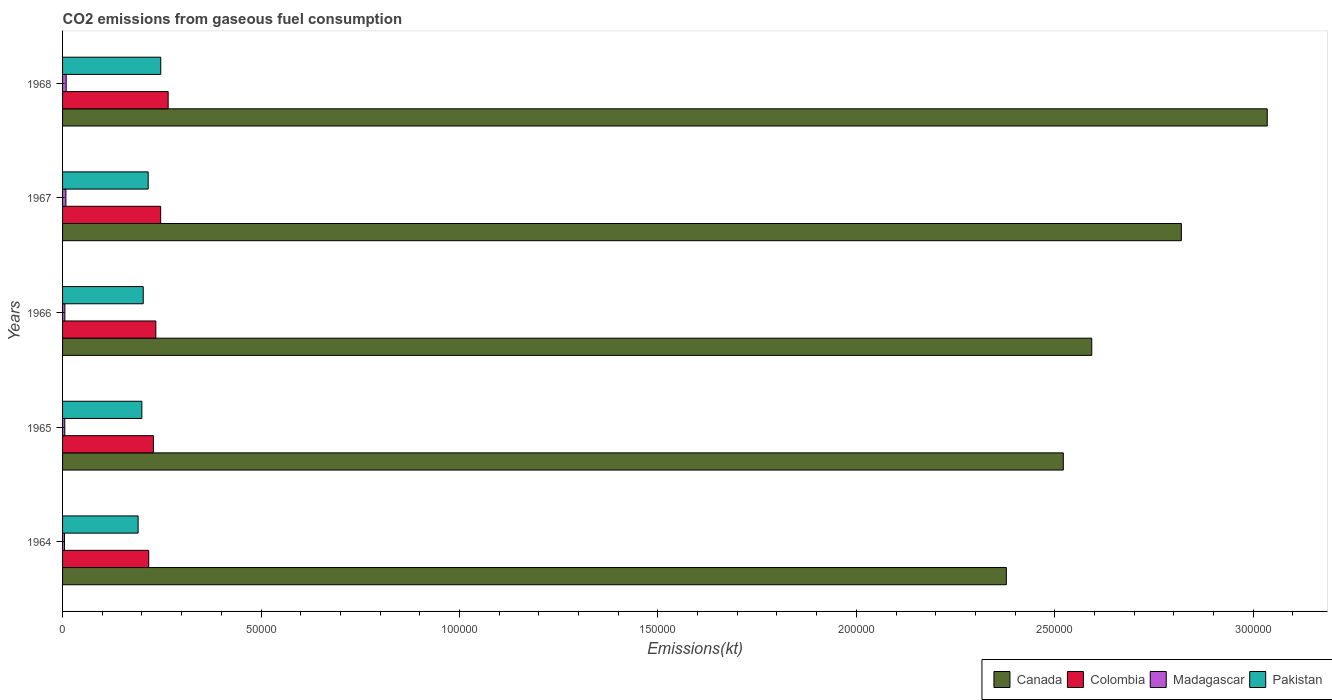How many groups of bars are there?
Your response must be concise. 5. Are the number of bars on each tick of the Y-axis equal?
Your answer should be compact. Yes. What is the label of the 3rd group of bars from the top?
Ensure brevity in your answer.  1966. What is the amount of CO2 emitted in Canada in 1966?
Your answer should be compact. 2.59e+05. Across all years, what is the maximum amount of CO2 emitted in Colombia?
Provide a succinct answer. 2.66e+04. Across all years, what is the minimum amount of CO2 emitted in Colombia?
Keep it short and to the point. 2.17e+04. In which year was the amount of CO2 emitted in Colombia maximum?
Provide a short and direct response. 1968. In which year was the amount of CO2 emitted in Pakistan minimum?
Provide a short and direct response. 1964. What is the total amount of CO2 emitted in Pakistan in the graph?
Ensure brevity in your answer.  1.06e+05. What is the difference between the amount of CO2 emitted in Madagascar in 1966 and that in 1967?
Offer a terse response. -264.02. What is the difference between the amount of CO2 emitted in Madagascar in 1967 and the amount of CO2 emitted in Colombia in 1968?
Make the answer very short. -2.58e+04. What is the average amount of CO2 emitted in Pakistan per year?
Ensure brevity in your answer.  2.11e+04. In the year 1966, what is the difference between the amount of CO2 emitted in Colombia and amount of CO2 emitted in Canada?
Your answer should be very brief. -2.36e+05. What is the ratio of the amount of CO2 emitted in Canada in 1965 to that in 1966?
Your answer should be very brief. 0.97. What is the difference between the highest and the second highest amount of CO2 emitted in Madagascar?
Provide a short and direct response. 69.67. What is the difference between the highest and the lowest amount of CO2 emitted in Colombia?
Make the answer very short. 4895.44. Is the sum of the amount of CO2 emitted in Canada in 1966 and 1968 greater than the maximum amount of CO2 emitted in Colombia across all years?
Your answer should be very brief. Yes. Is it the case that in every year, the sum of the amount of CO2 emitted in Pakistan and amount of CO2 emitted in Madagascar is greater than the sum of amount of CO2 emitted in Canada and amount of CO2 emitted in Colombia?
Keep it short and to the point. No. What does the 3rd bar from the bottom in 1964 represents?
Provide a short and direct response. Madagascar. Are the values on the major ticks of X-axis written in scientific E-notation?
Your answer should be very brief. No. What is the title of the graph?
Offer a terse response. CO2 emissions from gaseous fuel consumption. What is the label or title of the X-axis?
Make the answer very short. Emissions(kt). What is the label or title of the Y-axis?
Make the answer very short. Years. What is the Emissions(kt) of Canada in 1964?
Ensure brevity in your answer.  2.38e+05. What is the Emissions(kt) in Colombia in 1964?
Provide a short and direct response. 2.17e+04. What is the Emissions(kt) in Madagascar in 1964?
Your response must be concise. 484.04. What is the Emissions(kt) in Pakistan in 1964?
Your response must be concise. 1.90e+04. What is the Emissions(kt) in Canada in 1965?
Provide a short and direct response. 2.52e+05. What is the Emissions(kt) of Colombia in 1965?
Provide a succinct answer. 2.29e+04. What is the Emissions(kt) in Madagascar in 1965?
Make the answer very short. 557.38. What is the Emissions(kt) of Pakistan in 1965?
Provide a succinct answer. 2.00e+04. What is the Emissions(kt) of Canada in 1966?
Give a very brief answer. 2.59e+05. What is the Emissions(kt) of Colombia in 1966?
Offer a terse response. 2.35e+04. What is the Emissions(kt) in Madagascar in 1966?
Keep it short and to the point. 579.39. What is the Emissions(kt) of Pakistan in 1966?
Your answer should be very brief. 2.03e+04. What is the Emissions(kt) in Canada in 1967?
Make the answer very short. 2.82e+05. What is the Emissions(kt) in Colombia in 1967?
Keep it short and to the point. 2.47e+04. What is the Emissions(kt) of Madagascar in 1967?
Make the answer very short. 843.41. What is the Emissions(kt) in Pakistan in 1967?
Your answer should be very brief. 2.16e+04. What is the Emissions(kt) in Canada in 1968?
Your response must be concise. 3.04e+05. What is the Emissions(kt) in Colombia in 1968?
Provide a short and direct response. 2.66e+04. What is the Emissions(kt) in Madagascar in 1968?
Provide a short and direct response. 913.08. What is the Emissions(kt) of Pakistan in 1968?
Your answer should be compact. 2.47e+04. Across all years, what is the maximum Emissions(kt) in Canada?
Your response must be concise. 3.04e+05. Across all years, what is the maximum Emissions(kt) in Colombia?
Provide a short and direct response. 2.66e+04. Across all years, what is the maximum Emissions(kt) in Madagascar?
Provide a short and direct response. 913.08. Across all years, what is the maximum Emissions(kt) in Pakistan?
Ensure brevity in your answer.  2.47e+04. Across all years, what is the minimum Emissions(kt) in Canada?
Your answer should be very brief. 2.38e+05. Across all years, what is the minimum Emissions(kt) in Colombia?
Keep it short and to the point. 2.17e+04. Across all years, what is the minimum Emissions(kt) in Madagascar?
Give a very brief answer. 484.04. Across all years, what is the minimum Emissions(kt) of Pakistan?
Your answer should be very brief. 1.90e+04. What is the total Emissions(kt) of Canada in the graph?
Your answer should be compact. 1.33e+06. What is the total Emissions(kt) in Colombia in the graph?
Make the answer very short. 1.19e+05. What is the total Emissions(kt) in Madagascar in the graph?
Ensure brevity in your answer.  3377.31. What is the total Emissions(kt) in Pakistan in the graph?
Give a very brief answer. 1.06e+05. What is the difference between the Emissions(kt) of Canada in 1964 and that in 1965?
Your answer should be very brief. -1.44e+04. What is the difference between the Emissions(kt) of Colombia in 1964 and that in 1965?
Offer a very short reply. -1177.11. What is the difference between the Emissions(kt) in Madagascar in 1964 and that in 1965?
Give a very brief answer. -73.34. What is the difference between the Emissions(kt) of Pakistan in 1964 and that in 1965?
Your response must be concise. -938.75. What is the difference between the Emissions(kt) of Canada in 1964 and that in 1966?
Make the answer very short. -2.15e+04. What is the difference between the Emissions(kt) in Colombia in 1964 and that in 1966?
Make the answer very short. -1793.16. What is the difference between the Emissions(kt) in Madagascar in 1964 and that in 1966?
Provide a succinct answer. -95.34. What is the difference between the Emissions(kt) of Pakistan in 1964 and that in 1966?
Your answer should be compact. -1290.78. What is the difference between the Emissions(kt) in Canada in 1964 and that in 1967?
Offer a terse response. -4.41e+04. What is the difference between the Emissions(kt) of Colombia in 1964 and that in 1967?
Your response must be concise. -3006.94. What is the difference between the Emissions(kt) of Madagascar in 1964 and that in 1967?
Give a very brief answer. -359.37. What is the difference between the Emissions(kt) in Pakistan in 1964 and that in 1967?
Provide a succinct answer. -2537.56. What is the difference between the Emissions(kt) of Canada in 1964 and that in 1968?
Keep it short and to the point. -6.57e+04. What is the difference between the Emissions(kt) of Colombia in 1964 and that in 1968?
Ensure brevity in your answer.  -4895.44. What is the difference between the Emissions(kt) in Madagascar in 1964 and that in 1968?
Make the answer very short. -429.04. What is the difference between the Emissions(kt) in Pakistan in 1964 and that in 1968?
Your response must be concise. -5702.19. What is the difference between the Emissions(kt) of Canada in 1965 and that in 1966?
Ensure brevity in your answer.  -7165.32. What is the difference between the Emissions(kt) in Colombia in 1965 and that in 1966?
Offer a very short reply. -616.06. What is the difference between the Emissions(kt) in Madagascar in 1965 and that in 1966?
Offer a very short reply. -22. What is the difference between the Emissions(kt) of Pakistan in 1965 and that in 1966?
Provide a succinct answer. -352.03. What is the difference between the Emissions(kt) in Canada in 1965 and that in 1967?
Provide a succinct answer. -2.97e+04. What is the difference between the Emissions(kt) of Colombia in 1965 and that in 1967?
Your answer should be compact. -1829.83. What is the difference between the Emissions(kt) in Madagascar in 1965 and that in 1967?
Provide a short and direct response. -286.03. What is the difference between the Emissions(kt) in Pakistan in 1965 and that in 1967?
Offer a terse response. -1598.81. What is the difference between the Emissions(kt) in Canada in 1965 and that in 1968?
Offer a very short reply. -5.14e+04. What is the difference between the Emissions(kt) of Colombia in 1965 and that in 1968?
Your answer should be compact. -3718.34. What is the difference between the Emissions(kt) of Madagascar in 1965 and that in 1968?
Make the answer very short. -355.7. What is the difference between the Emissions(kt) of Pakistan in 1965 and that in 1968?
Your answer should be very brief. -4763.43. What is the difference between the Emissions(kt) of Canada in 1966 and that in 1967?
Offer a very short reply. -2.26e+04. What is the difference between the Emissions(kt) of Colombia in 1966 and that in 1967?
Your answer should be very brief. -1213.78. What is the difference between the Emissions(kt) of Madagascar in 1966 and that in 1967?
Offer a very short reply. -264.02. What is the difference between the Emissions(kt) of Pakistan in 1966 and that in 1967?
Provide a succinct answer. -1246.78. What is the difference between the Emissions(kt) of Canada in 1966 and that in 1968?
Ensure brevity in your answer.  -4.42e+04. What is the difference between the Emissions(kt) in Colombia in 1966 and that in 1968?
Offer a very short reply. -3102.28. What is the difference between the Emissions(kt) of Madagascar in 1966 and that in 1968?
Offer a very short reply. -333.7. What is the difference between the Emissions(kt) of Pakistan in 1966 and that in 1968?
Provide a short and direct response. -4411.4. What is the difference between the Emissions(kt) of Canada in 1967 and that in 1968?
Your answer should be very brief. -2.16e+04. What is the difference between the Emissions(kt) in Colombia in 1967 and that in 1968?
Keep it short and to the point. -1888.51. What is the difference between the Emissions(kt) of Madagascar in 1967 and that in 1968?
Ensure brevity in your answer.  -69.67. What is the difference between the Emissions(kt) in Pakistan in 1967 and that in 1968?
Your answer should be compact. -3164.62. What is the difference between the Emissions(kt) in Canada in 1964 and the Emissions(kt) in Colombia in 1965?
Give a very brief answer. 2.15e+05. What is the difference between the Emissions(kt) in Canada in 1964 and the Emissions(kt) in Madagascar in 1965?
Give a very brief answer. 2.37e+05. What is the difference between the Emissions(kt) of Canada in 1964 and the Emissions(kt) of Pakistan in 1965?
Ensure brevity in your answer.  2.18e+05. What is the difference between the Emissions(kt) of Colombia in 1964 and the Emissions(kt) of Madagascar in 1965?
Give a very brief answer. 2.12e+04. What is the difference between the Emissions(kt) in Colombia in 1964 and the Emissions(kt) in Pakistan in 1965?
Your answer should be compact. 1734.49. What is the difference between the Emissions(kt) of Madagascar in 1964 and the Emissions(kt) of Pakistan in 1965?
Offer a terse response. -1.95e+04. What is the difference between the Emissions(kt) in Canada in 1964 and the Emissions(kt) in Colombia in 1966?
Offer a terse response. 2.14e+05. What is the difference between the Emissions(kt) of Canada in 1964 and the Emissions(kt) of Madagascar in 1966?
Offer a terse response. 2.37e+05. What is the difference between the Emissions(kt) in Canada in 1964 and the Emissions(kt) in Pakistan in 1966?
Your answer should be very brief. 2.17e+05. What is the difference between the Emissions(kt) of Colombia in 1964 and the Emissions(kt) of Madagascar in 1966?
Your answer should be very brief. 2.11e+04. What is the difference between the Emissions(kt) of Colombia in 1964 and the Emissions(kt) of Pakistan in 1966?
Offer a very short reply. 1382.46. What is the difference between the Emissions(kt) in Madagascar in 1964 and the Emissions(kt) in Pakistan in 1966?
Your answer should be very brief. -1.98e+04. What is the difference between the Emissions(kt) in Canada in 1964 and the Emissions(kt) in Colombia in 1967?
Ensure brevity in your answer.  2.13e+05. What is the difference between the Emissions(kt) of Canada in 1964 and the Emissions(kt) of Madagascar in 1967?
Your response must be concise. 2.37e+05. What is the difference between the Emissions(kt) in Canada in 1964 and the Emissions(kt) in Pakistan in 1967?
Make the answer very short. 2.16e+05. What is the difference between the Emissions(kt) of Colombia in 1964 and the Emissions(kt) of Madagascar in 1967?
Offer a terse response. 2.09e+04. What is the difference between the Emissions(kt) in Colombia in 1964 and the Emissions(kt) in Pakistan in 1967?
Offer a very short reply. 135.68. What is the difference between the Emissions(kt) of Madagascar in 1964 and the Emissions(kt) of Pakistan in 1967?
Offer a very short reply. -2.11e+04. What is the difference between the Emissions(kt) in Canada in 1964 and the Emissions(kt) in Colombia in 1968?
Your answer should be very brief. 2.11e+05. What is the difference between the Emissions(kt) in Canada in 1964 and the Emissions(kt) in Madagascar in 1968?
Provide a succinct answer. 2.37e+05. What is the difference between the Emissions(kt) in Canada in 1964 and the Emissions(kt) in Pakistan in 1968?
Provide a short and direct response. 2.13e+05. What is the difference between the Emissions(kt) in Colombia in 1964 and the Emissions(kt) in Madagascar in 1968?
Your answer should be very brief. 2.08e+04. What is the difference between the Emissions(kt) of Colombia in 1964 and the Emissions(kt) of Pakistan in 1968?
Ensure brevity in your answer.  -3028.94. What is the difference between the Emissions(kt) of Madagascar in 1964 and the Emissions(kt) of Pakistan in 1968?
Your answer should be very brief. -2.43e+04. What is the difference between the Emissions(kt) in Canada in 1965 and the Emissions(kt) in Colombia in 1966?
Your answer should be very brief. 2.29e+05. What is the difference between the Emissions(kt) of Canada in 1965 and the Emissions(kt) of Madagascar in 1966?
Provide a short and direct response. 2.52e+05. What is the difference between the Emissions(kt) of Canada in 1965 and the Emissions(kt) of Pakistan in 1966?
Make the answer very short. 2.32e+05. What is the difference between the Emissions(kt) in Colombia in 1965 and the Emissions(kt) in Madagascar in 1966?
Give a very brief answer. 2.23e+04. What is the difference between the Emissions(kt) of Colombia in 1965 and the Emissions(kt) of Pakistan in 1966?
Offer a very short reply. 2559.57. What is the difference between the Emissions(kt) in Madagascar in 1965 and the Emissions(kt) in Pakistan in 1966?
Offer a very short reply. -1.98e+04. What is the difference between the Emissions(kt) in Canada in 1965 and the Emissions(kt) in Colombia in 1967?
Your answer should be very brief. 2.27e+05. What is the difference between the Emissions(kt) of Canada in 1965 and the Emissions(kt) of Madagascar in 1967?
Make the answer very short. 2.51e+05. What is the difference between the Emissions(kt) in Canada in 1965 and the Emissions(kt) in Pakistan in 1967?
Provide a succinct answer. 2.31e+05. What is the difference between the Emissions(kt) in Colombia in 1965 and the Emissions(kt) in Madagascar in 1967?
Offer a very short reply. 2.20e+04. What is the difference between the Emissions(kt) in Colombia in 1965 and the Emissions(kt) in Pakistan in 1967?
Give a very brief answer. 1312.79. What is the difference between the Emissions(kt) of Madagascar in 1965 and the Emissions(kt) of Pakistan in 1967?
Give a very brief answer. -2.10e+04. What is the difference between the Emissions(kt) of Canada in 1965 and the Emissions(kt) of Colombia in 1968?
Offer a terse response. 2.26e+05. What is the difference between the Emissions(kt) of Canada in 1965 and the Emissions(kt) of Madagascar in 1968?
Provide a short and direct response. 2.51e+05. What is the difference between the Emissions(kt) of Canada in 1965 and the Emissions(kt) of Pakistan in 1968?
Make the answer very short. 2.27e+05. What is the difference between the Emissions(kt) in Colombia in 1965 and the Emissions(kt) in Madagascar in 1968?
Your response must be concise. 2.20e+04. What is the difference between the Emissions(kt) in Colombia in 1965 and the Emissions(kt) in Pakistan in 1968?
Ensure brevity in your answer.  -1851.84. What is the difference between the Emissions(kt) in Madagascar in 1965 and the Emissions(kt) in Pakistan in 1968?
Offer a very short reply. -2.42e+04. What is the difference between the Emissions(kt) of Canada in 1966 and the Emissions(kt) of Colombia in 1967?
Give a very brief answer. 2.35e+05. What is the difference between the Emissions(kt) of Canada in 1966 and the Emissions(kt) of Madagascar in 1967?
Provide a short and direct response. 2.58e+05. What is the difference between the Emissions(kt) of Canada in 1966 and the Emissions(kt) of Pakistan in 1967?
Provide a short and direct response. 2.38e+05. What is the difference between the Emissions(kt) in Colombia in 1966 and the Emissions(kt) in Madagascar in 1967?
Offer a very short reply. 2.27e+04. What is the difference between the Emissions(kt) of Colombia in 1966 and the Emissions(kt) of Pakistan in 1967?
Make the answer very short. 1928.84. What is the difference between the Emissions(kt) in Madagascar in 1966 and the Emissions(kt) in Pakistan in 1967?
Provide a succinct answer. -2.10e+04. What is the difference between the Emissions(kt) of Canada in 1966 and the Emissions(kt) of Colombia in 1968?
Offer a terse response. 2.33e+05. What is the difference between the Emissions(kt) in Canada in 1966 and the Emissions(kt) in Madagascar in 1968?
Provide a short and direct response. 2.58e+05. What is the difference between the Emissions(kt) of Canada in 1966 and the Emissions(kt) of Pakistan in 1968?
Provide a succinct answer. 2.35e+05. What is the difference between the Emissions(kt) of Colombia in 1966 and the Emissions(kt) of Madagascar in 1968?
Your answer should be very brief. 2.26e+04. What is the difference between the Emissions(kt) of Colombia in 1966 and the Emissions(kt) of Pakistan in 1968?
Keep it short and to the point. -1235.78. What is the difference between the Emissions(kt) of Madagascar in 1966 and the Emissions(kt) of Pakistan in 1968?
Give a very brief answer. -2.42e+04. What is the difference between the Emissions(kt) of Canada in 1967 and the Emissions(kt) of Colombia in 1968?
Your answer should be compact. 2.55e+05. What is the difference between the Emissions(kt) of Canada in 1967 and the Emissions(kt) of Madagascar in 1968?
Your answer should be compact. 2.81e+05. What is the difference between the Emissions(kt) in Canada in 1967 and the Emissions(kt) in Pakistan in 1968?
Keep it short and to the point. 2.57e+05. What is the difference between the Emissions(kt) in Colombia in 1967 and the Emissions(kt) in Madagascar in 1968?
Provide a succinct answer. 2.38e+04. What is the difference between the Emissions(kt) in Colombia in 1967 and the Emissions(kt) in Pakistan in 1968?
Offer a very short reply. -22. What is the difference between the Emissions(kt) of Madagascar in 1967 and the Emissions(kt) of Pakistan in 1968?
Your answer should be compact. -2.39e+04. What is the average Emissions(kt) of Canada per year?
Offer a very short reply. 2.67e+05. What is the average Emissions(kt) of Colombia per year?
Your response must be concise. 2.39e+04. What is the average Emissions(kt) of Madagascar per year?
Offer a very short reply. 675.46. What is the average Emissions(kt) of Pakistan per year?
Your answer should be compact. 2.11e+04. In the year 1964, what is the difference between the Emissions(kt) of Canada and Emissions(kt) of Colombia?
Offer a terse response. 2.16e+05. In the year 1964, what is the difference between the Emissions(kt) of Canada and Emissions(kt) of Madagascar?
Keep it short and to the point. 2.37e+05. In the year 1964, what is the difference between the Emissions(kt) in Canada and Emissions(kt) in Pakistan?
Offer a very short reply. 2.19e+05. In the year 1964, what is the difference between the Emissions(kt) of Colombia and Emissions(kt) of Madagascar?
Give a very brief answer. 2.12e+04. In the year 1964, what is the difference between the Emissions(kt) in Colombia and Emissions(kt) in Pakistan?
Provide a succinct answer. 2673.24. In the year 1964, what is the difference between the Emissions(kt) of Madagascar and Emissions(kt) of Pakistan?
Offer a very short reply. -1.86e+04. In the year 1965, what is the difference between the Emissions(kt) of Canada and Emissions(kt) of Colombia?
Make the answer very short. 2.29e+05. In the year 1965, what is the difference between the Emissions(kt) of Canada and Emissions(kt) of Madagascar?
Offer a terse response. 2.52e+05. In the year 1965, what is the difference between the Emissions(kt) in Canada and Emissions(kt) in Pakistan?
Ensure brevity in your answer.  2.32e+05. In the year 1965, what is the difference between the Emissions(kt) of Colombia and Emissions(kt) of Madagascar?
Offer a very short reply. 2.23e+04. In the year 1965, what is the difference between the Emissions(kt) in Colombia and Emissions(kt) in Pakistan?
Your answer should be compact. 2911.6. In the year 1965, what is the difference between the Emissions(kt) of Madagascar and Emissions(kt) of Pakistan?
Offer a terse response. -1.94e+04. In the year 1966, what is the difference between the Emissions(kt) of Canada and Emissions(kt) of Colombia?
Your answer should be very brief. 2.36e+05. In the year 1966, what is the difference between the Emissions(kt) in Canada and Emissions(kt) in Madagascar?
Offer a terse response. 2.59e+05. In the year 1966, what is the difference between the Emissions(kt) in Canada and Emissions(kt) in Pakistan?
Provide a short and direct response. 2.39e+05. In the year 1966, what is the difference between the Emissions(kt) in Colombia and Emissions(kt) in Madagascar?
Your answer should be compact. 2.29e+04. In the year 1966, what is the difference between the Emissions(kt) of Colombia and Emissions(kt) of Pakistan?
Offer a terse response. 3175.62. In the year 1966, what is the difference between the Emissions(kt) of Madagascar and Emissions(kt) of Pakistan?
Your answer should be compact. -1.97e+04. In the year 1967, what is the difference between the Emissions(kt) in Canada and Emissions(kt) in Colombia?
Provide a short and direct response. 2.57e+05. In the year 1967, what is the difference between the Emissions(kt) in Canada and Emissions(kt) in Madagascar?
Offer a terse response. 2.81e+05. In the year 1967, what is the difference between the Emissions(kt) in Canada and Emissions(kt) in Pakistan?
Make the answer very short. 2.60e+05. In the year 1967, what is the difference between the Emissions(kt) in Colombia and Emissions(kt) in Madagascar?
Provide a succinct answer. 2.39e+04. In the year 1967, what is the difference between the Emissions(kt) of Colombia and Emissions(kt) of Pakistan?
Offer a very short reply. 3142.62. In the year 1967, what is the difference between the Emissions(kt) in Madagascar and Emissions(kt) in Pakistan?
Provide a succinct answer. -2.07e+04. In the year 1968, what is the difference between the Emissions(kt) in Canada and Emissions(kt) in Colombia?
Keep it short and to the point. 2.77e+05. In the year 1968, what is the difference between the Emissions(kt) of Canada and Emissions(kt) of Madagascar?
Your answer should be compact. 3.03e+05. In the year 1968, what is the difference between the Emissions(kt) in Canada and Emissions(kt) in Pakistan?
Your answer should be very brief. 2.79e+05. In the year 1968, what is the difference between the Emissions(kt) in Colombia and Emissions(kt) in Madagascar?
Your response must be concise. 2.57e+04. In the year 1968, what is the difference between the Emissions(kt) of Colombia and Emissions(kt) of Pakistan?
Your answer should be compact. 1866.5. In the year 1968, what is the difference between the Emissions(kt) of Madagascar and Emissions(kt) of Pakistan?
Ensure brevity in your answer.  -2.38e+04. What is the ratio of the Emissions(kt) in Canada in 1964 to that in 1965?
Keep it short and to the point. 0.94. What is the ratio of the Emissions(kt) of Colombia in 1964 to that in 1965?
Offer a terse response. 0.95. What is the ratio of the Emissions(kt) in Madagascar in 1964 to that in 1965?
Provide a short and direct response. 0.87. What is the ratio of the Emissions(kt) of Pakistan in 1964 to that in 1965?
Provide a short and direct response. 0.95. What is the ratio of the Emissions(kt) in Canada in 1964 to that in 1966?
Provide a short and direct response. 0.92. What is the ratio of the Emissions(kt) of Colombia in 1964 to that in 1966?
Your answer should be compact. 0.92. What is the ratio of the Emissions(kt) of Madagascar in 1964 to that in 1966?
Offer a very short reply. 0.84. What is the ratio of the Emissions(kt) of Pakistan in 1964 to that in 1966?
Your answer should be compact. 0.94. What is the ratio of the Emissions(kt) in Canada in 1964 to that in 1967?
Offer a very short reply. 0.84. What is the ratio of the Emissions(kt) of Colombia in 1964 to that in 1967?
Your answer should be compact. 0.88. What is the ratio of the Emissions(kt) in Madagascar in 1964 to that in 1967?
Keep it short and to the point. 0.57. What is the ratio of the Emissions(kt) of Pakistan in 1964 to that in 1967?
Ensure brevity in your answer.  0.88. What is the ratio of the Emissions(kt) of Canada in 1964 to that in 1968?
Make the answer very short. 0.78. What is the ratio of the Emissions(kt) in Colombia in 1964 to that in 1968?
Your response must be concise. 0.82. What is the ratio of the Emissions(kt) in Madagascar in 1964 to that in 1968?
Offer a very short reply. 0.53. What is the ratio of the Emissions(kt) in Pakistan in 1964 to that in 1968?
Your response must be concise. 0.77. What is the ratio of the Emissions(kt) of Canada in 1965 to that in 1966?
Ensure brevity in your answer.  0.97. What is the ratio of the Emissions(kt) in Colombia in 1965 to that in 1966?
Ensure brevity in your answer.  0.97. What is the ratio of the Emissions(kt) in Madagascar in 1965 to that in 1966?
Provide a succinct answer. 0.96. What is the ratio of the Emissions(kt) of Pakistan in 1965 to that in 1966?
Provide a succinct answer. 0.98. What is the ratio of the Emissions(kt) in Canada in 1965 to that in 1967?
Provide a succinct answer. 0.89. What is the ratio of the Emissions(kt) in Colombia in 1965 to that in 1967?
Provide a short and direct response. 0.93. What is the ratio of the Emissions(kt) in Madagascar in 1965 to that in 1967?
Provide a short and direct response. 0.66. What is the ratio of the Emissions(kt) of Pakistan in 1965 to that in 1967?
Give a very brief answer. 0.93. What is the ratio of the Emissions(kt) of Canada in 1965 to that in 1968?
Keep it short and to the point. 0.83. What is the ratio of the Emissions(kt) of Colombia in 1965 to that in 1968?
Provide a short and direct response. 0.86. What is the ratio of the Emissions(kt) in Madagascar in 1965 to that in 1968?
Your response must be concise. 0.61. What is the ratio of the Emissions(kt) in Pakistan in 1965 to that in 1968?
Offer a very short reply. 0.81. What is the ratio of the Emissions(kt) of Canada in 1966 to that in 1967?
Your answer should be very brief. 0.92. What is the ratio of the Emissions(kt) of Colombia in 1966 to that in 1967?
Provide a short and direct response. 0.95. What is the ratio of the Emissions(kt) of Madagascar in 1966 to that in 1967?
Make the answer very short. 0.69. What is the ratio of the Emissions(kt) of Pakistan in 1966 to that in 1967?
Offer a very short reply. 0.94. What is the ratio of the Emissions(kt) in Canada in 1966 to that in 1968?
Your answer should be very brief. 0.85. What is the ratio of the Emissions(kt) in Colombia in 1966 to that in 1968?
Your answer should be very brief. 0.88. What is the ratio of the Emissions(kt) in Madagascar in 1966 to that in 1968?
Provide a short and direct response. 0.63. What is the ratio of the Emissions(kt) of Pakistan in 1966 to that in 1968?
Your response must be concise. 0.82. What is the ratio of the Emissions(kt) in Canada in 1967 to that in 1968?
Your answer should be compact. 0.93. What is the ratio of the Emissions(kt) of Colombia in 1967 to that in 1968?
Give a very brief answer. 0.93. What is the ratio of the Emissions(kt) in Madagascar in 1967 to that in 1968?
Ensure brevity in your answer.  0.92. What is the ratio of the Emissions(kt) of Pakistan in 1967 to that in 1968?
Make the answer very short. 0.87. What is the difference between the highest and the second highest Emissions(kt) in Canada?
Provide a short and direct response. 2.16e+04. What is the difference between the highest and the second highest Emissions(kt) of Colombia?
Ensure brevity in your answer.  1888.51. What is the difference between the highest and the second highest Emissions(kt) of Madagascar?
Provide a short and direct response. 69.67. What is the difference between the highest and the second highest Emissions(kt) of Pakistan?
Your response must be concise. 3164.62. What is the difference between the highest and the lowest Emissions(kt) of Canada?
Provide a short and direct response. 6.57e+04. What is the difference between the highest and the lowest Emissions(kt) in Colombia?
Keep it short and to the point. 4895.44. What is the difference between the highest and the lowest Emissions(kt) in Madagascar?
Ensure brevity in your answer.  429.04. What is the difference between the highest and the lowest Emissions(kt) of Pakistan?
Your answer should be very brief. 5702.19. 